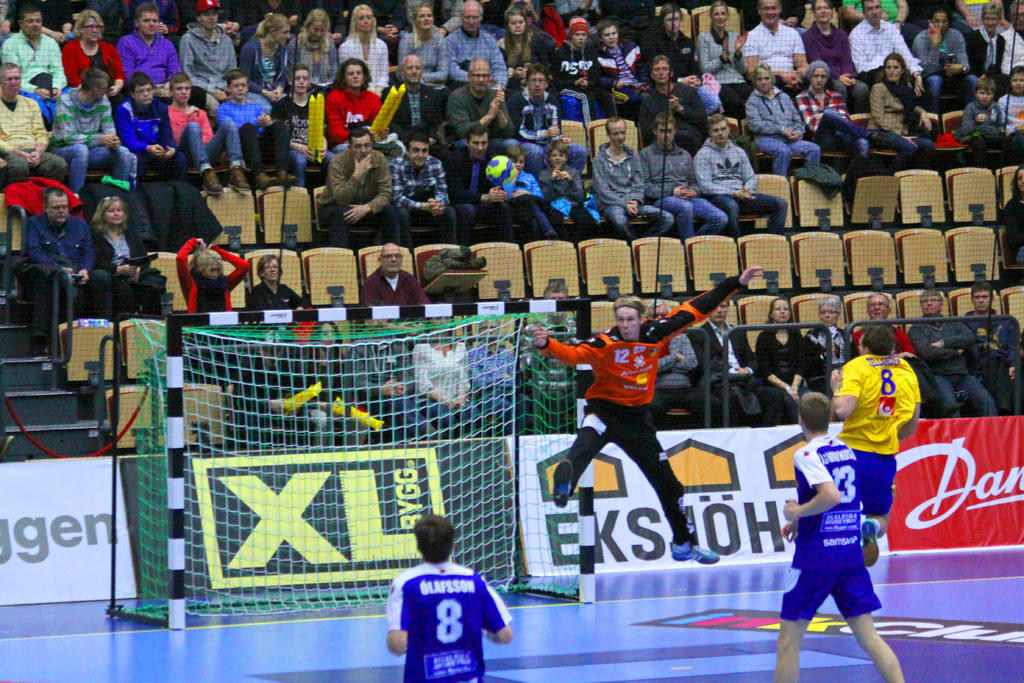Provide a one-sentence caption for the provided image.
Reference OCR token: Da, gen, XL, BLAFSSON, EKSJOH, 8, EAS XL Bygg sign on a black and gold poster board. 